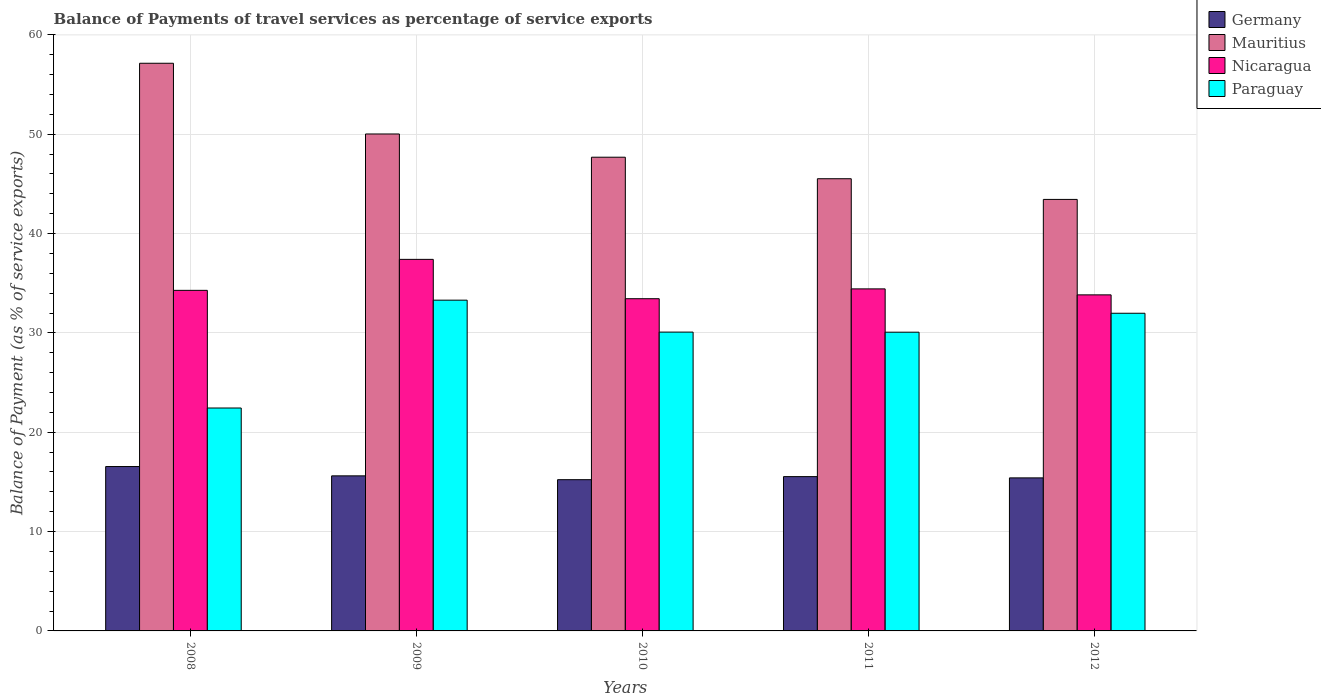How many different coloured bars are there?
Your answer should be very brief. 4. How many groups of bars are there?
Your answer should be compact. 5. Are the number of bars per tick equal to the number of legend labels?
Your answer should be compact. Yes. Are the number of bars on each tick of the X-axis equal?
Keep it short and to the point. Yes. What is the label of the 2nd group of bars from the left?
Provide a short and direct response. 2009. In how many cases, is the number of bars for a given year not equal to the number of legend labels?
Your answer should be compact. 0. What is the balance of payments of travel services in Paraguay in 2008?
Your answer should be very brief. 22.44. Across all years, what is the maximum balance of payments of travel services in Nicaragua?
Ensure brevity in your answer.  37.4. Across all years, what is the minimum balance of payments of travel services in Germany?
Your answer should be compact. 15.23. What is the total balance of payments of travel services in Mauritius in the graph?
Your answer should be very brief. 243.83. What is the difference between the balance of payments of travel services in Mauritius in 2011 and that in 2012?
Make the answer very short. 2.08. What is the difference between the balance of payments of travel services in Germany in 2011 and the balance of payments of travel services in Paraguay in 2012?
Your response must be concise. -16.44. What is the average balance of payments of travel services in Paraguay per year?
Provide a succinct answer. 29.57. In the year 2010, what is the difference between the balance of payments of travel services in Nicaragua and balance of payments of travel services in Paraguay?
Provide a succinct answer. 3.36. In how many years, is the balance of payments of travel services in Mauritius greater than 34 %?
Offer a very short reply. 5. What is the ratio of the balance of payments of travel services in Paraguay in 2010 to that in 2012?
Provide a succinct answer. 0.94. Is the difference between the balance of payments of travel services in Nicaragua in 2009 and 2010 greater than the difference between the balance of payments of travel services in Paraguay in 2009 and 2010?
Provide a succinct answer. Yes. What is the difference between the highest and the second highest balance of payments of travel services in Nicaragua?
Provide a short and direct response. 2.97. What is the difference between the highest and the lowest balance of payments of travel services in Paraguay?
Offer a very short reply. 10.86. In how many years, is the balance of payments of travel services in Germany greater than the average balance of payments of travel services in Germany taken over all years?
Provide a succinct answer. 1. What does the 2nd bar from the left in 2010 represents?
Your response must be concise. Mauritius. What does the 3rd bar from the right in 2008 represents?
Give a very brief answer. Mauritius. How many years are there in the graph?
Keep it short and to the point. 5. What is the difference between two consecutive major ticks on the Y-axis?
Your response must be concise. 10. Does the graph contain grids?
Make the answer very short. Yes. How many legend labels are there?
Offer a terse response. 4. What is the title of the graph?
Your answer should be very brief. Balance of Payments of travel services as percentage of service exports. What is the label or title of the X-axis?
Provide a succinct answer. Years. What is the label or title of the Y-axis?
Your response must be concise. Balance of Payment (as % of service exports). What is the Balance of Payment (as % of service exports) in Germany in 2008?
Keep it short and to the point. 16.55. What is the Balance of Payment (as % of service exports) of Mauritius in 2008?
Provide a short and direct response. 57.15. What is the Balance of Payment (as % of service exports) in Nicaragua in 2008?
Offer a terse response. 34.29. What is the Balance of Payment (as % of service exports) of Paraguay in 2008?
Provide a short and direct response. 22.44. What is the Balance of Payment (as % of service exports) of Germany in 2009?
Provide a short and direct response. 15.61. What is the Balance of Payment (as % of service exports) in Mauritius in 2009?
Your answer should be very brief. 50.03. What is the Balance of Payment (as % of service exports) of Nicaragua in 2009?
Provide a short and direct response. 37.4. What is the Balance of Payment (as % of service exports) in Paraguay in 2009?
Your answer should be compact. 33.3. What is the Balance of Payment (as % of service exports) in Germany in 2010?
Make the answer very short. 15.23. What is the Balance of Payment (as % of service exports) of Mauritius in 2010?
Give a very brief answer. 47.69. What is the Balance of Payment (as % of service exports) in Nicaragua in 2010?
Give a very brief answer. 33.44. What is the Balance of Payment (as % of service exports) of Paraguay in 2010?
Give a very brief answer. 30.08. What is the Balance of Payment (as % of service exports) of Germany in 2011?
Give a very brief answer. 15.53. What is the Balance of Payment (as % of service exports) of Mauritius in 2011?
Keep it short and to the point. 45.52. What is the Balance of Payment (as % of service exports) of Nicaragua in 2011?
Provide a succinct answer. 34.43. What is the Balance of Payment (as % of service exports) in Paraguay in 2011?
Keep it short and to the point. 30.07. What is the Balance of Payment (as % of service exports) of Germany in 2012?
Your answer should be compact. 15.41. What is the Balance of Payment (as % of service exports) in Mauritius in 2012?
Keep it short and to the point. 43.44. What is the Balance of Payment (as % of service exports) of Nicaragua in 2012?
Make the answer very short. 33.83. What is the Balance of Payment (as % of service exports) of Paraguay in 2012?
Give a very brief answer. 31.98. Across all years, what is the maximum Balance of Payment (as % of service exports) in Germany?
Your response must be concise. 16.55. Across all years, what is the maximum Balance of Payment (as % of service exports) of Mauritius?
Make the answer very short. 57.15. Across all years, what is the maximum Balance of Payment (as % of service exports) of Nicaragua?
Keep it short and to the point. 37.4. Across all years, what is the maximum Balance of Payment (as % of service exports) of Paraguay?
Your answer should be compact. 33.3. Across all years, what is the minimum Balance of Payment (as % of service exports) in Germany?
Provide a succinct answer. 15.23. Across all years, what is the minimum Balance of Payment (as % of service exports) of Mauritius?
Provide a short and direct response. 43.44. Across all years, what is the minimum Balance of Payment (as % of service exports) in Nicaragua?
Offer a very short reply. 33.44. Across all years, what is the minimum Balance of Payment (as % of service exports) of Paraguay?
Ensure brevity in your answer.  22.44. What is the total Balance of Payment (as % of service exports) in Germany in the graph?
Give a very brief answer. 78.33. What is the total Balance of Payment (as % of service exports) of Mauritius in the graph?
Provide a short and direct response. 243.83. What is the total Balance of Payment (as % of service exports) in Nicaragua in the graph?
Offer a terse response. 173.4. What is the total Balance of Payment (as % of service exports) in Paraguay in the graph?
Your answer should be compact. 147.87. What is the difference between the Balance of Payment (as % of service exports) of Germany in 2008 and that in 2009?
Give a very brief answer. 0.94. What is the difference between the Balance of Payment (as % of service exports) in Mauritius in 2008 and that in 2009?
Ensure brevity in your answer.  7.12. What is the difference between the Balance of Payment (as % of service exports) of Nicaragua in 2008 and that in 2009?
Provide a short and direct response. -3.12. What is the difference between the Balance of Payment (as % of service exports) of Paraguay in 2008 and that in 2009?
Give a very brief answer. -10.86. What is the difference between the Balance of Payment (as % of service exports) in Germany in 2008 and that in 2010?
Offer a terse response. 1.32. What is the difference between the Balance of Payment (as % of service exports) in Mauritius in 2008 and that in 2010?
Make the answer very short. 9.46. What is the difference between the Balance of Payment (as % of service exports) of Nicaragua in 2008 and that in 2010?
Ensure brevity in your answer.  0.84. What is the difference between the Balance of Payment (as % of service exports) of Paraguay in 2008 and that in 2010?
Provide a short and direct response. -7.64. What is the difference between the Balance of Payment (as % of service exports) in Mauritius in 2008 and that in 2011?
Offer a very short reply. 11.62. What is the difference between the Balance of Payment (as % of service exports) in Nicaragua in 2008 and that in 2011?
Keep it short and to the point. -0.15. What is the difference between the Balance of Payment (as % of service exports) of Paraguay in 2008 and that in 2011?
Your answer should be compact. -7.63. What is the difference between the Balance of Payment (as % of service exports) of Germany in 2008 and that in 2012?
Keep it short and to the point. 1.14. What is the difference between the Balance of Payment (as % of service exports) of Mauritius in 2008 and that in 2012?
Offer a very short reply. 13.71. What is the difference between the Balance of Payment (as % of service exports) of Nicaragua in 2008 and that in 2012?
Give a very brief answer. 0.45. What is the difference between the Balance of Payment (as % of service exports) of Paraguay in 2008 and that in 2012?
Offer a very short reply. -9.54. What is the difference between the Balance of Payment (as % of service exports) in Germany in 2009 and that in 2010?
Provide a succinct answer. 0.38. What is the difference between the Balance of Payment (as % of service exports) of Mauritius in 2009 and that in 2010?
Offer a very short reply. 2.34. What is the difference between the Balance of Payment (as % of service exports) of Nicaragua in 2009 and that in 2010?
Keep it short and to the point. 3.96. What is the difference between the Balance of Payment (as % of service exports) in Paraguay in 2009 and that in 2010?
Make the answer very short. 3.21. What is the difference between the Balance of Payment (as % of service exports) of Germany in 2009 and that in 2011?
Provide a short and direct response. 0.08. What is the difference between the Balance of Payment (as % of service exports) in Mauritius in 2009 and that in 2011?
Give a very brief answer. 4.5. What is the difference between the Balance of Payment (as % of service exports) of Nicaragua in 2009 and that in 2011?
Your answer should be compact. 2.97. What is the difference between the Balance of Payment (as % of service exports) of Paraguay in 2009 and that in 2011?
Offer a terse response. 3.23. What is the difference between the Balance of Payment (as % of service exports) of Germany in 2009 and that in 2012?
Your answer should be very brief. 0.2. What is the difference between the Balance of Payment (as % of service exports) in Mauritius in 2009 and that in 2012?
Your answer should be compact. 6.59. What is the difference between the Balance of Payment (as % of service exports) of Nicaragua in 2009 and that in 2012?
Offer a terse response. 3.57. What is the difference between the Balance of Payment (as % of service exports) in Paraguay in 2009 and that in 2012?
Give a very brief answer. 1.32. What is the difference between the Balance of Payment (as % of service exports) of Germany in 2010 and that in 2011?
Provide a succinct answer. -0.31. What is the difference between the Balance of Payment (as % of service exports) of Mauritius in 2010 and that in 2011?
Provide a short and direct response. 2.17. What is the difference between the Balance of Payment (as % of service exports) of Nicaragua in 2010 and that in 2011?
Ensure brevity in your answer.  -0.99. What is the difference between the Balance of Payment (as % of service exports) in Paraguay in 2010 and that in 2011?
Keep it short and to the point. 0.01. What is the difference between the Balance of Payment (as % of service exports) in Germany in 2010 and that in 2012?
Give a very brief answer. -0.18. What is the difference between the Balance of Payment (as % of service exports) in Mauritius in 2010 and that in 2012?
Keep it short and to the point. 4.25. What is the difference between the Balance of Payment (as % of service exports) of Nicaragua in 2010 and that in 2012?
Ensure brevity in your answer.  -0.39. What is the difference between the Balance of Payment (as % of service exports) of Paraguay in 2010 and that in 2012?
Provide a short and direct response. -1.9. What is the difference between the Balance of Payment (as % of service exports) of Germany in 2011 and that in 2012?
Give a very brief answer. 0.13. What is the difference between the Balance of Payment (as % of service exports) in Mauritius in 2011 and that in 2012?
Ensure brevity in your answer.  2.08. What is the difference between the Balance of Payment (as % of service exports) of Nicaragua in 2011 and that in 2012?
Your answer should be very brief. 0.6. What is the difference between the Balance of Payment (as % of service exports) in Paraguay in 2011 and that in 2012?
Keep it short and to the point. -1.91. What is the difference between the Balance of Payment (as % of service exports) in Germany in 2008 and the Balance of Payment (as % of service exports) in Mauritius in 2009?
Your response must be concise. -33.48. What is the difference between the Balance of Payment (as % of service exports) of Germany in 2008 and the Balance of Payment (as % of service exports) of Nicaragua in 2009?
Your response must be concise. -20.86. What is the difference between the Balance of Payment (as % of service exports) of Germany in 2008 and the Balance of Payment (as % of service exports) of Paraguay in 2009?
Your answer should be compact. -16.75. What is the difference between the Balance of Payment (as % of service exports) in Mauritius in 2008 and the Balance of Payment (as % of service exports) in Nicaragua in 2009?
Your answer should be compact. 19.74. What is the difference between the Balance of Payment (as % of service exports) in Mauritius in 2008 and the Balance of Payment (as % of service exports) in Paraguay in 2009?
Keep it short and to the point. 23.85. What is the difference between the Balance of Payment (as % of service exports) of Nicaragua in 2008 and the Balance of Payment (as % of service exports) of Paraguay in 2009?
Offer a very short reply. 0.99. What is the difference between the Balance of Payment (as % of service exports) in Germany in 2008 and the Balance of Payment (as % of service exports) in Mauritius in 2010?
Keep it short and to the point. -31.14. What is the difference between the Balance of Payment (as % of service exports) of Germany in 2008 and the Balance of Payment (as % of service exports) of Nicaragua in 2010?
Your response must be concise. -16.89. What is the difference between the Balance of Payment (as % of service exports) in Germany in 2008 and the Balance of Payment (as % of service exports) in Paraguay in 2010?
Ensure brevity in your answer.  -13.53. What is the difference between the Balance of Payment (as % of service exports) in Mauritius in 2008 and the Balance of Payment (as % of service exports) in Nicaragua in 2010?
Provide a succinct answer. 23.7. What is the difference between the Balance of Payment (as % of service exports) of Mauritius in 2008 and the Balance of Payment (as % of service exports) of Paraguay in 2010?
Your answer should be compact. 27.06. What is the difference between the Balance of Payment (as % of service exports) in Nicaragua in 2008 and the Balance of Payment (as % of service exports) in Paraguay in 2010?
Your answer should be very brief. 4.2. What is the difference between the Balance of Payment (as % of service exports) in Germany in 2008 and the Balance of Payment (as % of service exports) in Mauritius in 2011?
Offer a very short reply. -28.97. What is the difference between the Balance of Payment (as % of service exports) in Germany in 2008 and the Balance of Payment (as % of service exports) in Nicaragua in 2011?
Your response must be concise. -17.88. What is the difference between the Balance of Payment (as % of service exports) in Germany in 2008 and the Balance of Payment (as % of service exports) in Paraguay in 2011?
Your answer should be compact. -13.52. What is the difference between the Balance of Payment (as % of service exports) in Mauritius in 2008 and the Balance of Payment (as % of service exports) in Nicaragua in 2011?
Your answer should be very brief. 22.71. What is the difference between the Balance of Payment (as % of service exports) of Mauritius in 2008 and the Balance of Payment (as % of service exports) of Paraguay in 2011?
Give a very brief answer. 27.07. What is the difference between the Balance of Payment (as % of service exports) in Nicaragua in 2008 and the Balance of Payment (as % of service exports) in Paraguay in 2011?
Make the answer very short. 4.21. What is the difference between the Balance of Payment (as % of service exports) in Germany in 2008 and the Balance of Payment (as % of service exports) in Mauritius in 2012?
Give a very brief answer. -26.89. What is the difference between the Balance of Payment (as % of service exports) of Germany in 2008 and the Balance of Payment (as % of service exports) of Nicaragua in 2012?
Offer a terse response. -17.28. What is the difference between the Balance of Payment (as % of service exports) of Germany in 2008 and the Balance of Payment (as % of service exports) of Paraguay in 2012?
Make the answer very short. -15.43. What is the difference between the Balance of Payment (as % of service exports) in Mauritius in 2008 and the Balance of Payment (as % of service exports) in Nicaragua in 2012?
Your answer should be compact. 23.32. What is the difference between the Balance of Payment (as % of service exports) in Mauritius in 2008 and the Balance of Payment (as % of service exports) in Paraguay in 2012?
Keep it short and to the point. 25.17. What is the difference between the Balance of Payment (as % of service exports) in Nicaragua in 2008 and the Balance of Payment (as % of service exports) in Paraguay in 2012?
Keep it short and to the point. 2.31. What is the difference between the Balance of Payment (as % of service exports) in Germany in 2009 and the Balance of Payment (as % of service exports) in Mauritius in 2010?
Offer a very short reply. -32.08. What is the difference between the Balance of Payment (as % of service exports) in Germany in 2009 and the Balance of Payment (as % of service exports) in Nicaragua in 2010?
Offer a terse response. -17.83. What is the difference between the Balance of Payment (as % of service exports) of Germany in 2009 and the Balance of Payment (as % of service exports) of Paraguay in 2010?
Ensure brevity in your answer.  -14.47. What is the difference between the Balance of Payment (as % of service exports) in Mauritius in 2009 and the Balance of Payment (as % of service exports) in Nicaragua in 2010?
Keep it short and to the point. 16.58. What is the difference between the Balance of Payment (as % of service exports) in Mauritius in 2009 and the Balance of Payment (as % of service exports) in Paraguay in 2010?
Give a very brief answer. 19.94. What is the difference between the Balance of Payment (as % of service exports) in Nicaragua in 2009 and the Balance of Payment (as % of service exports) in Paraguay in 2010?
Your answer should be very brief. 7.32. What is the difference between the Balance of Payment (as % of service exports) in Germany in 2009 and the Balance of Payment (as % of service exports) in Mauritius in 2011?
Offer a very short reply. -29.91. What is the difference between the Balance of Payment (as % of service exports) in Germany in 2009 and the Balance of Payment (as % of service exports) in Nicaragua in 2011?
Provide a short and direct response. -18.82. What is the difference between the Balance of Payment (as % of service exports) in Germany in 2009 and the Balance of Payment (as % of service exports) in Paraguay in 2011?
Ensure brevity in your answer.  -14.46. What is the difference between the Balance of Payment (as % of service exports) of Mauritius in 2009 and the Balance of Payment (as % of service exports) of Nicaragua in 2011?
Your response must be concise. 15.59. What is the difference between the Balance of Payment (as % of service exports) of Mauritius in 2009 and the Balance of Payment (as % of service exports) of Paraguay in 2011?
Your answer should be compact. 19.95. What is the difference between the Balance of Payment (as % of service exports) of Nicaragua in 2009 and the Balance of Payment (as % of service exports) of Paraguay in 2011?
Provide a succinct answer. 7.33. What is the difference between the Balance of Payment (as % of service exports) of Germany in 2009 and the Balance of Payment (as % of service exports) of Mauritius in 2012?
Your response must be concise. -27.83. What is the difference between the Balance of Payment (as % of service exports) in Germany in 2009 and the Balance of Payment (as % of service exports) in Nicaragua in 2012?
Offer a very short reply. -18.22. What is the difference between the Balance of Payment (as % of service exports) in Germany in 2009 and the Balance of Payment (as % of service exports) in Paraguay in 2012?
Provide a short and direct response. -16.37. What is the difference between the Balance of Payment (as % of service exports) of Mauritius in 2009 and the Balance of Payment (as % of service exports) of Nicaragua in 2012?
Provide a short and direct response. 16.2. What is the difference between the Balance of Payment (as % of service exports) of Mauritius in 2009 and the Balance of Payment (as % of service exports) of Paraguay in 2012?
Give a very brief answer. 18.05. What is the difference between the Balance of Payment (as % of service exports) of Nicaragua in 2009 and the Balance of Payment (as % of service exports) of Paraguay in 2012?
Your answer should be very brief. 5.43. What is the difference between the Balance of Payment (as % of service exports) of Germany in 2010 and the Balance of Payment (as % of service exports) of Mauritius in 2011?
Keep it short and to the point. -30.3. What is the difference between the Balance of Payment (as % of service exports) in Germany in 2010 and the Balance of Payment (as % of service exports) in Nicaragua in 2011?
Your answer should be very brief. -19.21. What is the difference between the Balance of Payment (as % of service exports) of Germany in 2010 and the Balance of Payment (as % of service exports) of Paraguay in 2011?
Your answer should be compact. -14.85. What is the difference between the Balance of Payment (as % of service exports) of Mauritius in 2010 and the Balance of Payment (as % of service exports) of Nicaragua in 2011?
Your response must be concise. 13.26. What is the difference between the Balance of Payment (as % of service exports) in Mauritius in 2010 and the Balance of Payment (as % of service exports) in Paraguay in 2011?
Provide a short and direct response. 17.62. What is the difference between the Balance of Payment (as % of service exports) of Nicaragua in 2010 and the Balance of Payment (as % of service exports) of Paraguay in 2011?
Keep it short and to the point. 3.37. What is the difference between the Balance of Payment (as % of service exports) of Germany in 2010 and the Balance of Payment (as % of service exports) of Mauritius in 2012?
Provide a succinct answer. -28.22. What is the difference between the Balance of Payment (as % of service exports) of Germany in 2010 and the Balance of Payment (as % of service exports) of Nicaragua in 2012?
Make the answer very short. -18.61. What is the difference between the Balance of Payment (as % of service exports) in Germany in 2010 and the Balance of Payment (as % of service exports) in Paraguay in 2012?
Your answer should be compact. -16.75. What is the difference between the Balance of Payment (as % of service exports) of Mauritius in 2010 and the Balance of Payment (as % of service exports) of Nicaragua in 2012?
Your answer should be compact. 13.86. What is the difference between the Balance of Payment (as % of service exports) in Mauritius in 2010 and the Balance of Payment (as % of service exports) in Paraguay in 2012?
Ensure brevity in your answer.  15.71. What is the difference between the Balance of Payment (as % of service exports) in Nicaragua in 2010 and the Balance of Payment (as % of service exports) in Paraguay in 2012?
Offer a very short reply. 1.47. What is the difference between the Balance of Payment (as % of service exports) in Germany in 2011 and the Balance of Payment (as % of service exports) in Mauritius in 2012?
Ensure brevity in your answer.  -27.91. What is the difference between the Balance of Payment (as % of service exports) of Germany in 2011 and the Balance of Payment (as % of service exports) of Nicaragua in 2012?
Provide a succinct answer. -18.3. What is the difference between the Balance of Payment (as % of service exports) of Germany in 2011 and the Balance of Payment (as % of service exports) of Paraguay in 2012?
Your response must be concise. -16.44. What is the difference between the Balance of Payment (as % of service exports) of Mauritius in 2011 and the Balance of Payment (as % of service exports) of Nicaragua in 2012?
Provide a succinct answer. 11.69. What is the difference between the Balance of Payment (as % of service exports) of Mauritius in 2011 and the Balance of Payment (as % of service exports) of Paraguay in 2012?
Your answer should be very brief. 13.54. What is the difference between the Balance of Payment (as % of service exports) of Nicaragua in 2011 and the Balance of Payment (as % of service exports) of Paraguay in 2012?
Your response must be concise. 2.45. What is the average Balance of Payment (as % of service exports) in Germany per year?
Provide a short and direct response. 15.67. What is the average Balance of Payment (as % of service exports) in Mauritius per year?
Keep it short and to the point. 48.77. What is the average Balance of Payment (as % of service exports) in Nicaragua per year?
Your answer should be compact. 34.68. What is the average Balance of Payment (as % of service exports) of Paraguay per year?
Offer a terse response. 29.57. In the year 2008, what is the difference between the Balance of Payment (as % of service exports) in Germany and Balance of Payment (as % of service exports) in Mauritius?
Ensure brevity in your answer.  -40.6. In the year 2008, what is the difference between the Balance of Payment (as % of service exports) in Germany and Balance of Payment (as % of service exports) in Nicaragua?
Provide a short and direct response. -17.74. In the year 2008, what is the difference between the Balance of Payment (as % of service exports) of Germany and Balance of Payment (as % of service exports) of Paraguay?
Ensure brevity in your answer.  -5.89. In the year 2008, what is the difference between the Balance of Payment (as % of service exports) in Mauritius and Balance of Payment (as % of service exports) in Nicaragua?
Ensure brevity in your answer.  22.86. In the year 2008, what is the difference between the Balance of Payment (as % of service exports) in Mauritius and Balance of Payment (as % of service exports) in Paraguay?
Ensure brevity in your answer.  34.71. In the year 2008, what is the difference between the Balance of Payment (as % of service exports) of Nicaragua and Balance of Payment (as % of service exports) of Paraguay?
Provide a succinct answer. 11.84. In the year 2009, what is the difference between the Balance of Payment (as % of service exports) of Germany and Balance of Payment (as % of service exports) of Mauritius?
Make the answer very short. -34.42. In the year 2009, what is the difference between the Balance of Payment (as % of service exports) in Germany and Balance of Payment (as % of service exports) in Nicaragua?
Give a very brief answer. -21.79. In the year 2009, what is the difference between the Balance of Payment (as % of service exports) in Germany and Balance of Payment (as % of service exports) in Paraguay?
Make the answer very short. -17.69. In the year 2009, what is the difference between the Balance of Payment (as % of service exports) of Mauritius and Balance of Payment (as % of service exports) of Nicaragua?
Make the answer very short. 12.62. In the year 2009, what is the difference between the Balance of Payment (as % of service exports) of Mauritius and Balance of Payment (as % of service exports) of Paraguay?
Give a very brief answer. 16.73. In the year 2009, what is the difference between the Balance of Payment (as % of service exports) of Nicaragua and Balance of Payment (as % of service exports) of Paraguay?
Provide a succinct answer. 4.11. In the year 2010, what is the difference between the Balance of Payment (as % of service exports) in Germany and Balance of Payment (as % of service exports) in Mauritius?
Offer a terse response. -32.46. In the year 2010, what is the difference between the Balance of Payment (as % of service exports) in Germany and Balance of Payment (as % of service exports) in Nicaragua?
Keep it short and to the point. -18.22. In the year 2010, what is the difference between the Balance of Payment (as % of service exports) of Germany and Balance of Payment (as % of service exports) of Paraguay?
Offer a very short reply. -14.86. In the year 2010, what is the difference between the Balance of Payment (as % of service exports) in Mauritius and Balance of Payment (as % of service exports) in Nicaragua?
Offer a terse response. 14.25. In the year 2010, what is the difference between the Balance of Payment (as % of service exports) of Mauritius and Balance of Payment (as % of service exports) of Paraguay?
Ensure brevity in your answer.  17.61. In the year 2010, what is the difference between the Balance of Payment (as % of service exports) in Nicaragua and Balance of Payment (as % of service exports) in Paraguay?
Your answer should be very brief. 3.36. In the year 2011, what is the difference between the Balance of Payment (as % of service exports) in Germany and Balance of Payment (as % of service exports) in Mauritius?
Your answer should be very brief. -29.99. In the year 2011, what is the difference between the Balance of Payment (as % of service exports) of Germany and Balance of Payment (as % of service exports) of Nicaragua?
Your answer should be very brief. -18.9. In the year 2011, what is the difference between the Balance of Payment (as % of service exports) of Germany and Balance of Payment (as % of service exports) of Paraguay?
Your response must be concise. -14.54. In the year 2011, what is the difference between the Balance of Payment (as % of service exports) of Mauritius and Balance of Payment (as % of service exports) of Nicaragua?
Your answer should be very brief. 11.09. In the year 2011, what is the difference between the Balance of Payment (as % of service exports) of Mauritius and Balance of Payment (as % of service exports) of Paraguay?
Make the answer very short. 15.45. In the year 2011, what is the difference between the Balance of Payment (as % of service exports) in Nicaragua and Balance of Payment (as % of service exports) in Paraguay?
Ensure brevity in your answer.  4.36. In the year 2012, what is the difference between the Balance of Payment (as % of service exports) in Germany and Balance of Payment (as % of service exports) in Mauritius?
Give a very brief answer. -28.03. In the year 2012, what is the difference between the Balance of Payment (as % of service exports) in Germany and Balance of Payment (as % of service exports) in Nicaragua?
Offer a very short reply. -18.42. In the year 2012, what is the difference between the Balance of Payment (as % of service exports) in Germany and Balance of Payment (as % of service exports) in Paraguay?
Provide a succinct answer. -16.57. In the year 2012, what is the difference between the Balance of Payment (as % of service exports) in Mauritius and Balance of Payment (as % of service exports) in Nicaragua?
Offer a terse response. 9.61. In the year 2012, what is the difference between the Balance of Payment (as % of service exports) of Mauritius and Balance of Payment (as % of service exports) of Paraguay?
Your answer should be very brief. 11.46. In the year 2012, what is the difference between the Balance of Payment (as % of service exports) of Nicaragua and Balance of Payment (as % of service exports) of Paraguay?
Provide a short and direct response. 1.85. What is the ratio of the Balance of Payment (as % of service exports) in Germany in 2008 to that in 2009?
Offer a terse response. 1.06. What is the ratio of the Balance of Payment (as % of service exports) of Mauritius in 2008 to that in 2009?
Your response must be concise. 1.14. What is the ratio of the Balance of Payment (as % of service exports) of Nicaragua in 2008 to that in 2009?
Offer a very short reply. 0.92. What is the ratio of the Balance of Payment (as % of service exports) in Paraguay in 2008 to that in 2009?
Give a very brief answer. 0.67. What is the ratio of the Balance of Payment (as % of service exports) of Germany in 2008 to that in 2010?
Make the answer very short. 1.09. What is the ratio of the Balance of Payment (as % of service exports) in Mauritius in 2008 to that in 2010?
Your answer should be very brief. 1.2. What is the ratio of the Balance of Payment (as % of service exports) in Nicaragua in 2008 to that in 2010?
Your response must be concise. 1.03. What is the ratio of the Balance of Payment (as % of service exports) in Paraguay in 2008 to that in 2010?
Ensure brevity in your answer.  0.75. What is the ratio of the Balance of Payment (as % of service exports) in Germany in 2008 to that in 2011?
Your response must be concise. 1.07. What is the ratio of the Balance of Payment (as % of service exports) in Mauritius in 2008 to that in 2011?
Make the answer very short. 1.26. What is the ratio of the Balance of Payment (as % of service exports) in Nicaragua in 2008 to that in 2011?
Offer a very short reply. 1. What is the ratio of the Balance of Payment (as % of service exports) of Paraguay in 2008 to that in 2011?
Provide a short and direct response. 0.75. What is the ratio of the Balance of Payment (as % of service exports) of Germany in 2008 to that in 2012?
Your response must be concise. 1.07. What is the ratio of the Balance of Payment (as % of service exports) of Mauritius in 2008 to that in 2012?
Provide a short and direct response. 1.32. What is the ratio of the Balance of Payment (as % of service exports) of Nicaragua in 2008 to that in 2012?
Make the answer very short. 1.01. What is the ratio of the Balance of Payment (as % of service exports) in Paraguay in 2008 to that in 2012?
Make the answer very short. 0.7. What is the ratio of the Balance of Payment (as % of service exports) in Germany in 2009 to that in 2010?
Make the answer very short. 1.03. What is the ratio of the Balance of Payment (as % of service exports) of Mauritius in 2009 to that in 2010?
Your answer should be very brief. 1.05. What is the ratio of the Balance of Payment (as % of service exports) of Nicaragua in 2009 to that in 2010?
Your answer should be very brief. 1.12. What is the ratio of the Balance of Payment (as % of service exports) in Paraguay in 2009 to that in 2010?
Your answer should be compact. 1.11. What is the ratio of the Balance of Payment (as % of service exports) in Mauritius in 2009 to that in 2011?
Your response must be concise. 1.1. What is the ratio of the Balance of Payment (as % of service exports) of Nicaragua in 2009 to that in 2011?
Provide a succinct answer. 1.09. What is the ratio of the Balance of Payment (as % of service exports) in Paraguay in 2009 to that in 2011?
Keep it short and to the point. 1.11. What is the ratio of the Balance of Payment (as % of service exports) of Germany in 2009 to that in 2012?
Provide a short and direct response. 1.01. What is the ratio of the Balance of Payment (as % of service exports) of Mauritius in 2009 to that in 2012?
Offer a terse response. 1.15. What is the ratio of the Balance of Payment (as % of service exports) of Nicaragua in 2009 to that in 2012?
Offer a terse response. 1.11. What is the ratio of the Balance of Payment (as % of service exports) in Paraguay in 2009 to that in 2012?
Offer a very short reply. 1.04. What is the ratio of the Balance of Payment (as % of service exports) of Germany in 2010 to that in 2011?
Ensure brevity in your answer.  0.98. What is the ratio of the Balance of Payment (as % of service exports) of Mauritius in 2010 to that in 2011?
Offer a terse response. 1.05. What is the ratio of the Balance of Payment (as % of service exports) of Nicaragua in 2010 to that in 2011?
Your answer should be very brief. 0.97. What is the ratio of the Balance of Payment (as % of service exports) in Mauritius in 2010 to that in 2012?
Provide a succinct answer. 1.1. What is the ratio of the Balance of Payment (as % of service exports) of Paraguay in 2010 to that in 2012?
Make the answer very short. 0.94. What is the ratio of the Balance of Payment (as % of service exports) of Germany in 2011 to that in 2012?
Give a very brief answer. 1.01. What is the ratio of the Balance of Payment (as % of service exports) in Mauritius in 2011 to that in 2012?
Make the answer very short. 1.05. What is the ratio of the Balance of Payment (as % of service exports) in Nicaragua in 2011 to that in 2012?
Your response must be concise. 1.02. What is the ratio of the Balance of Payment (as % of service exports) of Paraguay in 2011 to that in 2012?
Give a very brief answer. 0.94. What is the difference between the highest and the second highest Balance of Payment (as % of service exports) in Germany?
Give a very brief answer. 0.94. What is the difference between the highest and the second highest Balance of Payment (as % of service exports) of Mauritius?
Provide a short and direct response. 7.12. What is the difference between the highest and the second highest Balance of Payment (as % of service exports) of Nicaragua?
Your answer should be very brief. 2.97. What is the difference between the highest and the second highest Balance of Payment (as % of service exports) of Paraguay?
Ensure brevity in your answer.  1.32. What is the difference between the highest and the lowest Balance of Payment (as % of service exports) in Germany?
Offer a terse response. 1.32. What is the difference between the highest and the lowest Balance of Payment (as % of service exports) in Mauritius?
Ensure brevity in your answer.  13.71. What is the difference between the highest and the lowest Balance of Payment (as % of service exports) in Nicaragua?
Provide a succinct answer. 3.96. What is the difference between the highest and the lowest Balance of Payment (as % of service exports) in Paraguay?
Keep it short and to the point. 10.86. 